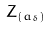<formula> <loc_0><loc_0><loc_500><loc_500>Z _ { ( a _ { \delta } ) }</formula> 